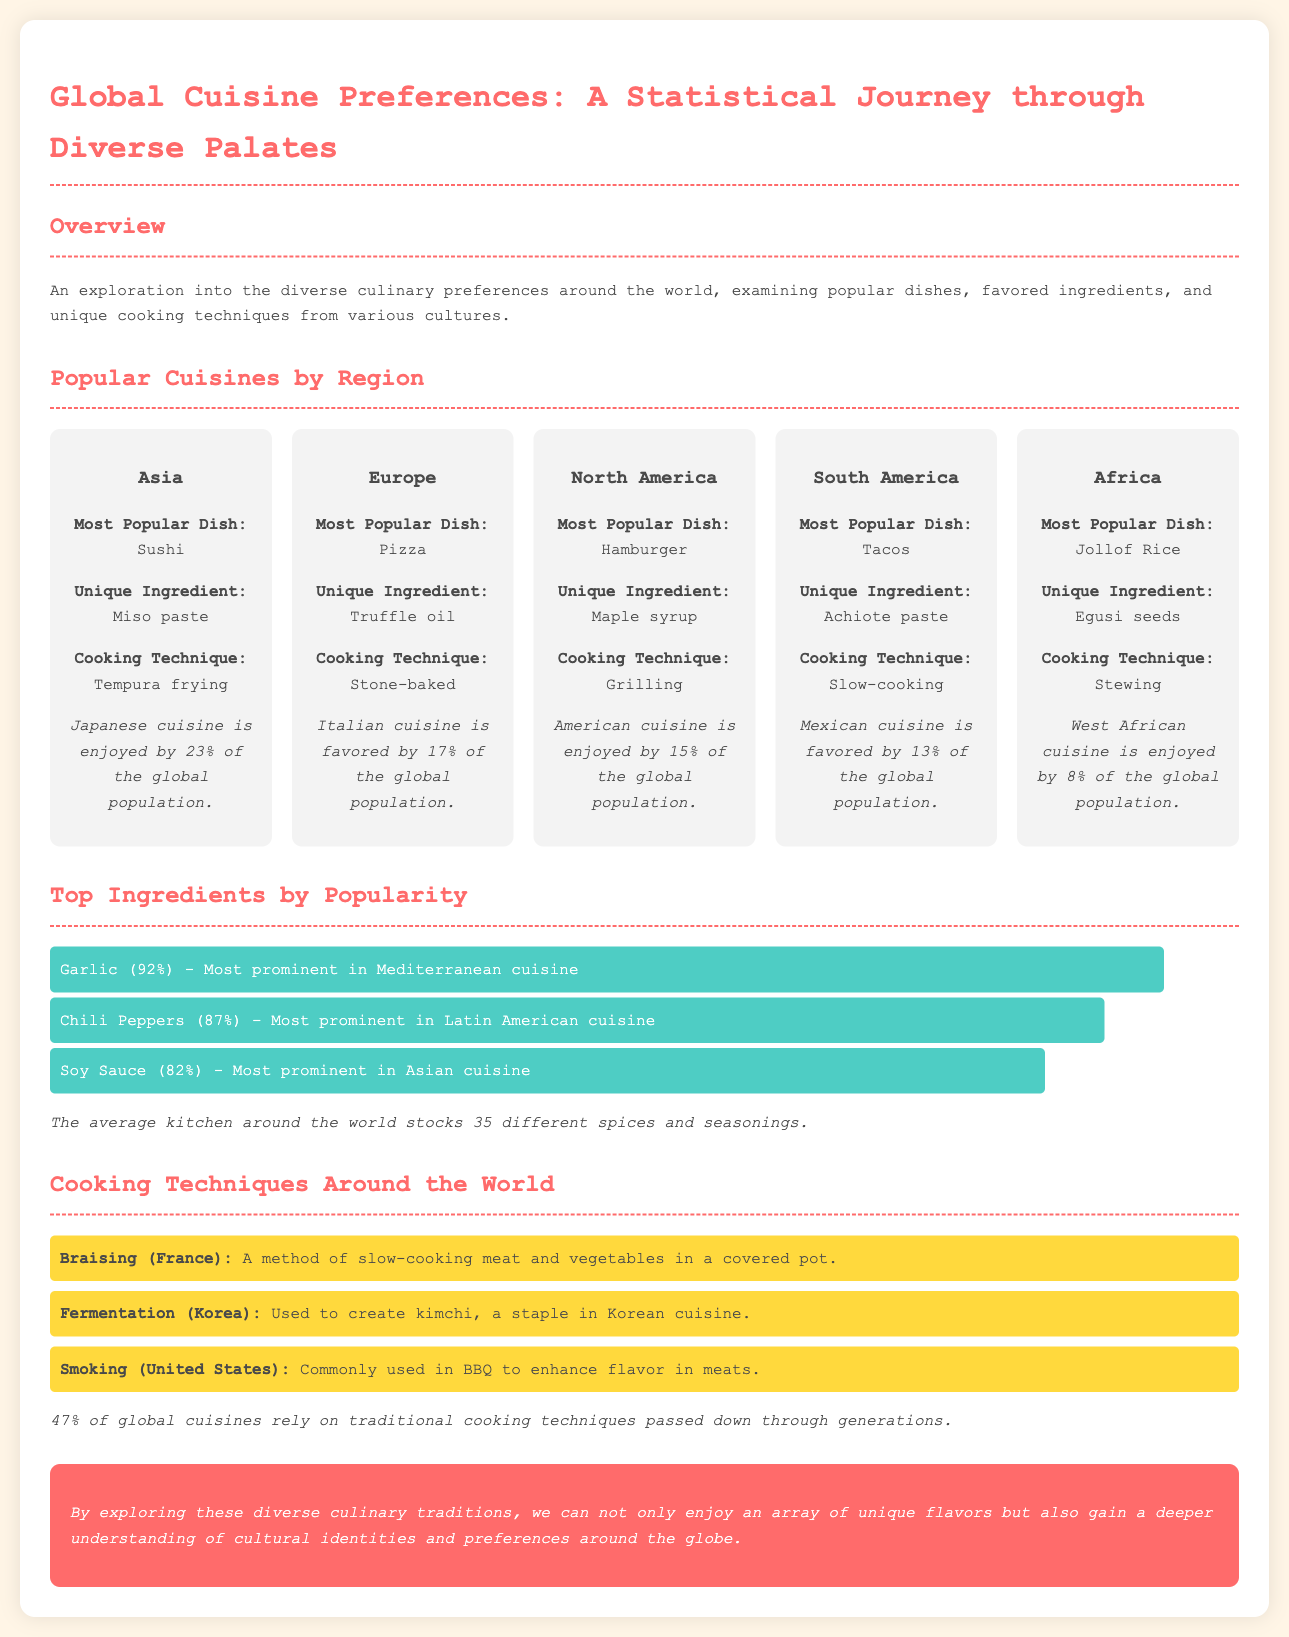What is the most popular dish in Asia? The document states that the most popular dish in Asia is Sushi.
Answer: Sushi Which ingredient is most prominent in Mediterranean cuisine? The document indicates that Garlic is most prominent in Mediterranean cuisine.
Answer: Garlic What percent of the global population enjoys Japanese cuisine? According to the document, Japanese cuisine is enjoyed by 23% of the global population.
Answer: 23% Which cooking technique is commonly used in BBQ in the United States? The document mentions that Smoking is commonly used in BBQ to enhance flavor in meats.
Answer: Smoking What is the unique ingredient used in Mexican cuisine? The document specifies that Achiote paste is a unique ingredient used in Mexican cuisine.
Answer: Achiote paste How many different spices and seasonings does the average kitchen stock? The document states that the average kitchen around the world stocks 35 different spices and seasonings.
Answer: 35 What cooking technique is used to create kimchi in Korean cuisine? The document explains that Fermentation is used to create kimchi in Korean cuisine.
Answer: Fermentation What percentage of global cuisines rely on traditional cooking techniques? The document notes that 47% of global cuisines rely on traditional cooking techniques.
Answer: 47% 